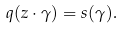Convert formula to latex. <formula><loc_0><loc_0><loc_500><loc_500>q ( z \cdot \gamma ) = s ( \gamma ) .</formula> 